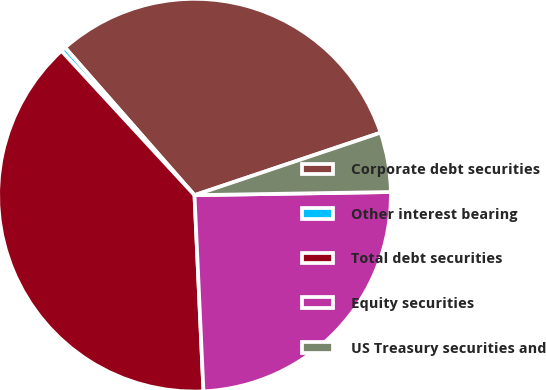<chart> <loc_0><loc_0><loc_500><loc_500><pie_chart><fcel>Corporate debt securities<fcel>Other interest bearing<fcel>Total debt securities<fcel>Equity securities<fcel>US Treasury securities and<nl><fcel>31.3%<fcel>0.4%<fcel>38.87%<fcel>24.53%<fcel>4.9%<nl></chart> 